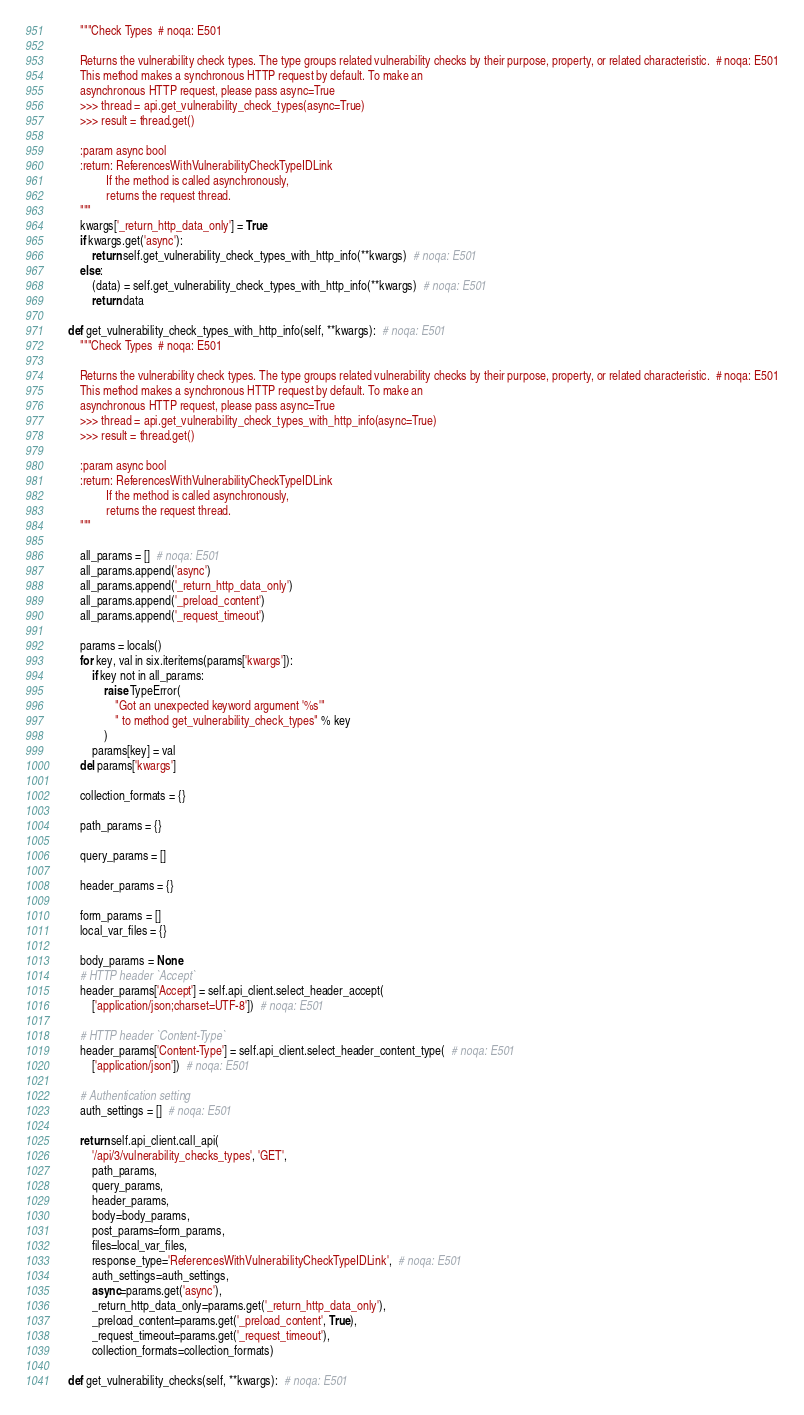Convert code to text. <code><loc_0><loc_0><loc_500><loc_500><_Python_>        """Check Types  # noqa: E501

        Returns the vulnerability check types. The type groups related vulnerability checks by their purpose, property, or related characteristic.  # noqa: E501
        This method makes a synchronous HTTP request by default. To make an
        asynchronous HTTP request, please pass async=True
        >>> thread = api.get_vulnerability_check_types(async=True)
        >>> result = thread.get()

        :param async bool
        :return: ReferencesWithVulnerabilityCheckTypeIDLink
                 If the method is called asynchronously,
                 returns the request thread.
        """
        kwargs['_return_http_data_only'] = True
        if kwargs.get('async'):
            return self.get_vulnerability_check_types_with_http_info(**kwargs)  # noqa: E501
        else:
            (data) = self.get_vulnerability_check_types_with_http_info(**kwargs)  # noqa: E501
            return data

    def get_vulnerability_check_types_with_http_info(self, **kwargs):  # noqa: E501
        """Check Types  # noqa: E501

        Returns the vulnerability check types. The type groups related vulnerability checks by their purpose, property, or related characteristic.  # noqa: E501
        This method makes a synchronous HTTP request by default. To make an
        asynchronous HTTP request, please pass async=True
        >>> thread = api.get_vulnerability_check_types_with_http_info(async=True)
        >>> result = thread.get()

        :param async bool
        :return: ReferencesWithVulnerabilityCheckTypeIDLink
                 If the method is called asynchronously,
                 returns the request thread.
        """

        all_params = []  # noqa: E501
        all_params.append('async')
        all_params.append('_return_http_data_only')
        all_params.append('_preload_content')
        all_params.append('_request_timeout')

        params = locals()
        for key, val in six.iteritems(params['kwargs']):
            if key not in all_params:
                raise TypeError(
                    "Got an unexpected keyword argument '%s'"
                    " to method get_vulnerability_check_types" % key
                )
            params[key] = val
        del params['kwargs']

        collection_formats = {}

        path_params = {}

        query_params = []

        header_params = {}

        form_params = []
        local_var_files = {}

        body_params = None
        # HTTP header `Accept`
        header_params['Accept'] = self.api_client.select_header_accept(
            ['application/json;charset=UTF-8'])  # noqa: E501

        # HTTP header `Content-Type`
        header_params['Content-Type'] = self.api_client.select_header_content_type(  # noqa: E501
            ['application/json'])  # noqa: E501

        # Authentication setting
        auth_settings = []  # noqa: E501

        return self.api_client.call_api(
            '/api/3/vulnerability_checks_types', 'GET',
            path_params,
            query_params,
            header_params,
            body=body_params,
            post_params=form_params,
            files=local_var_files,
            response_type='ReferencesWithVulnerabilityCheckTypeIDLink',  # noqa: E501
            auth_settings=auth_settings,
            async=params.get('async'),
            _return_http_data_only=params.get('_return_http_data_only'),
            _preload_content=params.get('_preload_content', True),
            _request_timeout=params.get('_request_timeout'),
            collection_formats=collection_formats)

    def get_vulnerability_checks(self, **kwargs):  # noqa: E501</code> 